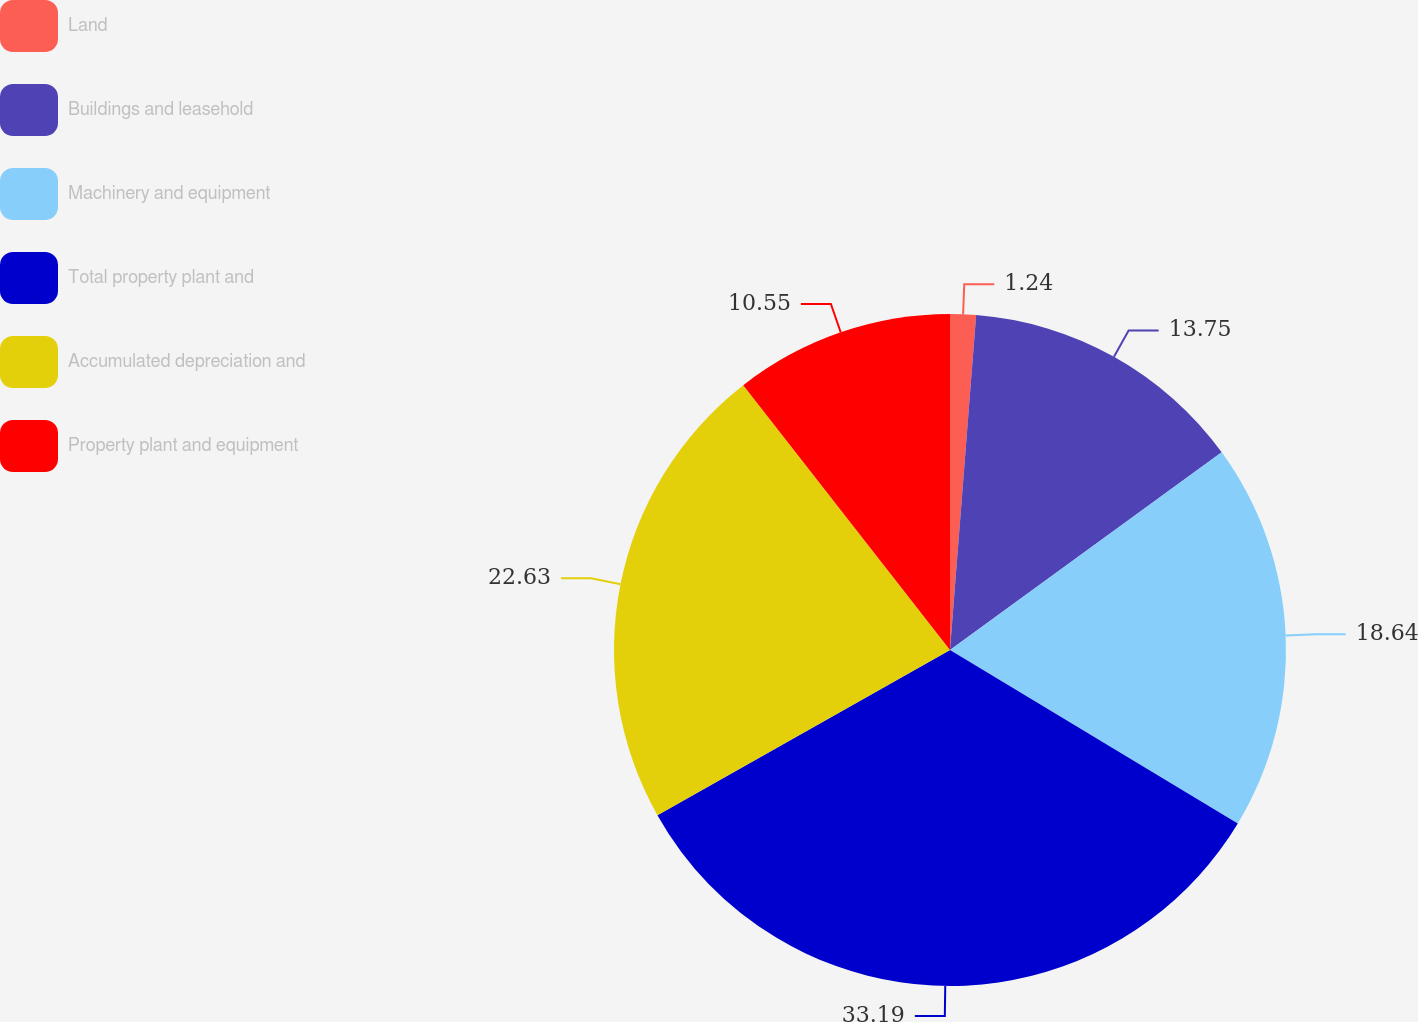Convert chart. <chart><loc_0><loc_0><loc_500><loc_500><pie_chart><fcel>Land<fcel>Buildings and leasehold<fcel>Machinery and equipment<fcel>Total property plant and<fcel>Accumulated depreciation and<fcel>Property plant and equipment<nl><fcel>1.24%<fcel>13.75%<fcel>18.64%<fcel>33.19%<fcel>22.63%<fcel>10.55%<nl></chart> 